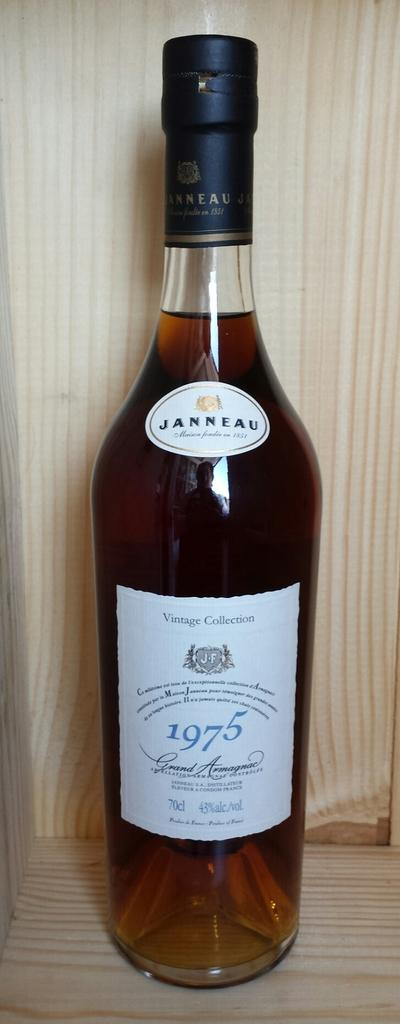<image>
Present a compact description of the photo's key features. a bottle of janneau vintage collection 1975 from france 